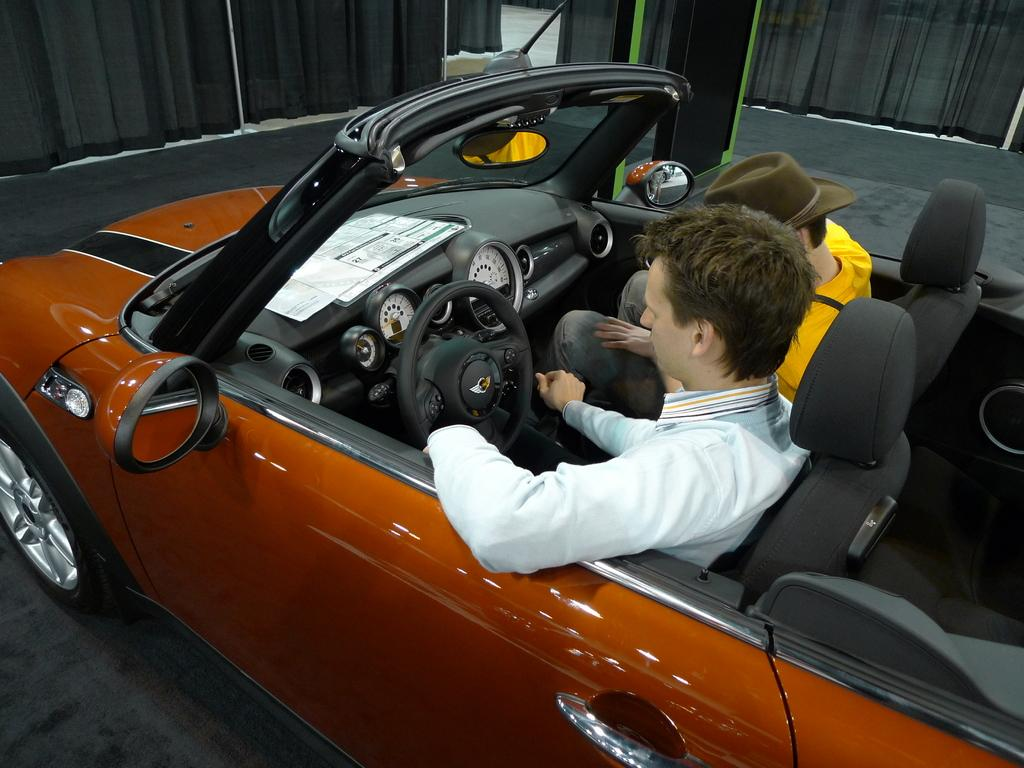How many people are in the image? There are two persons in the image. What are the persons doing in the image? The persons are sitting in a car. Where is the car located in the image? The car is on the floor. What can be seen in the background of the image? There are curtains and objects visible in the background of the image. What type of stew is being prepared in the car? There is no indication of any stew preparation in the image; the persons are simply sitting in the car. Where is the faucet located in the image? There is no faucet present in the image. 